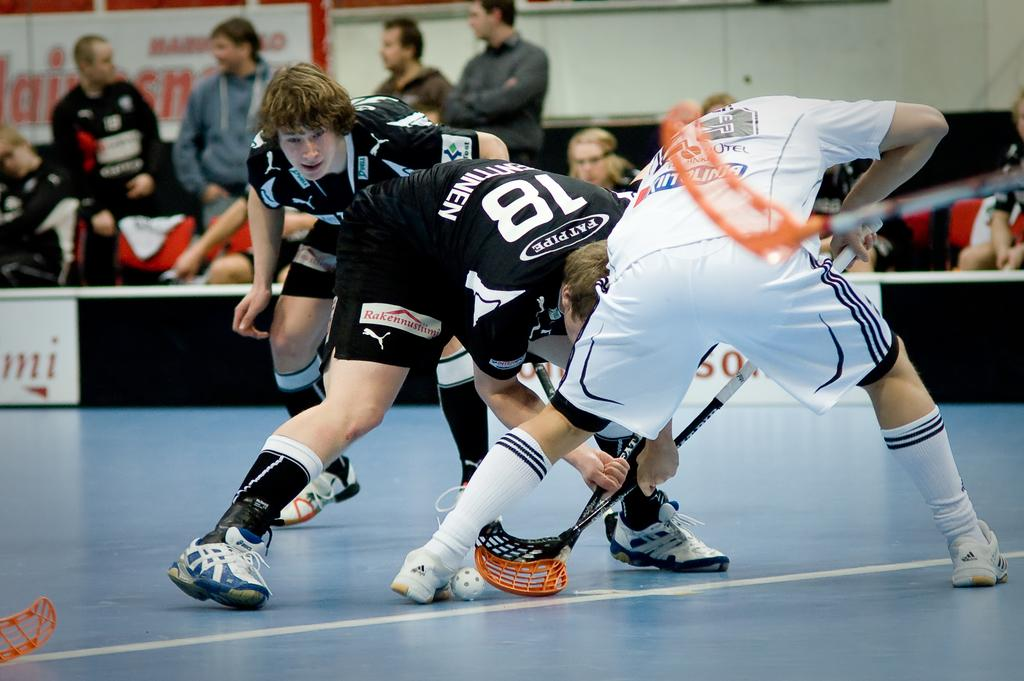<image>
Render a clear and concise summary of the photo. a person has the number 18 on their jersey 